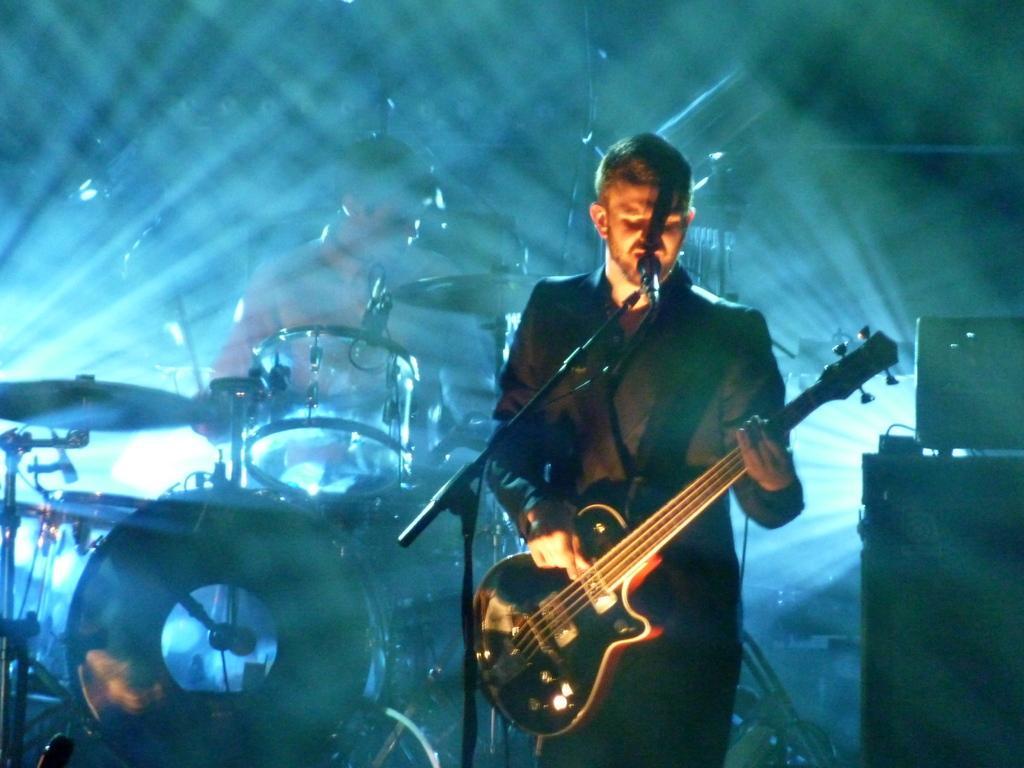Could you give a brief overview of what you see in this image? In the right a man is playing the guitar and also singing in the left a man is beating the drums. 